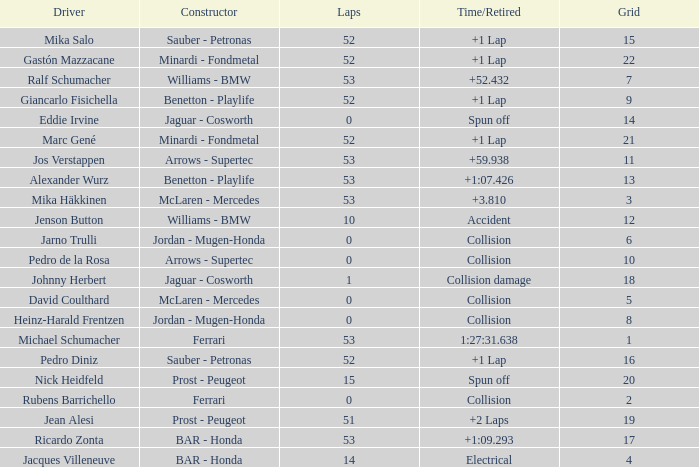What is the average Laps for a grid smaller than 17, and a Constructor of williams - bmw, driven by jenson button? 10.0. 